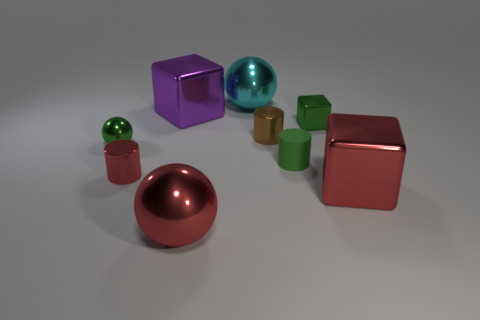Subtract all large red metallic blocks. How many blocks are left? 2 Subtract 2 spheres. How many spheres are left? 1 Subtract all purple cubes. How many cubes are left? 2 Add 1 red matte objects. How many objects exist? 10 Add 7 big blocks. How many big blocks are left? 9 Add 1 tiny yellow matte balls. How many tiny yellow matte balls exist? 1 Subtract 1 cyan spheres. How many objects are left? 8 Subtract all cubes. How many objects are left? 6 Subtract all yellow cylinders. Subtract all green balls. How many cylinders are left? 3 Subtract all yellow blocks. How many red spheres are left? 1 